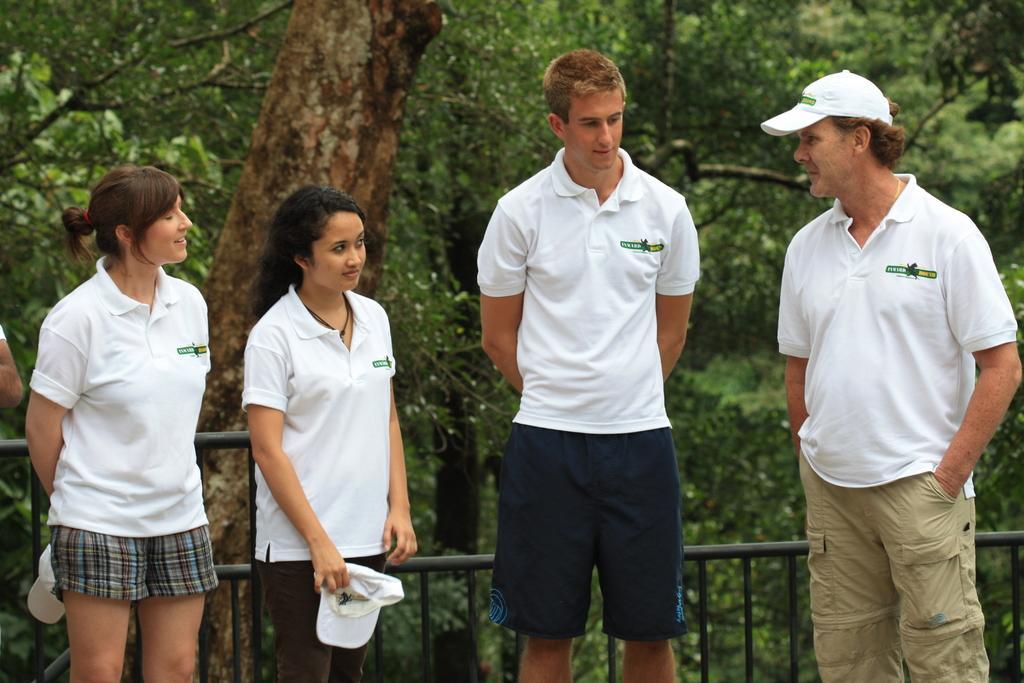Could you give a brief overview of what you see in this image? In this picture there are four persons standing and wearing white T-shirts and there is a fence behind them and there are trees in the background. 